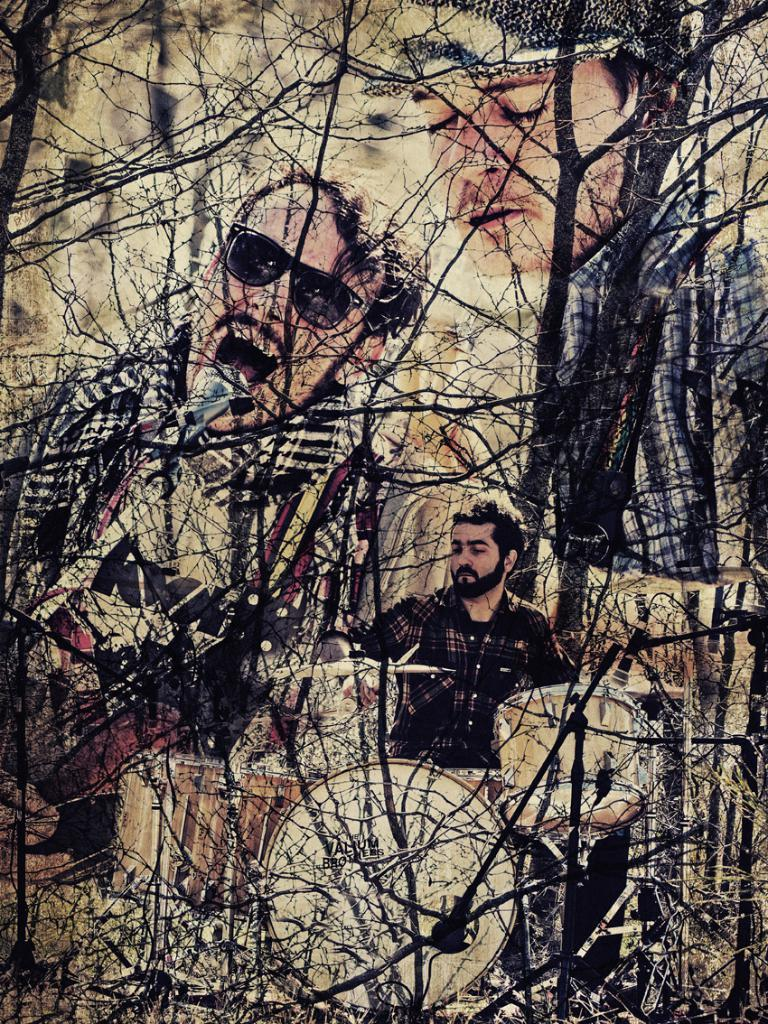How many people are in the image? There are persons in the image, but the exact number is not specified. What can be seen in the image besides the persons? There are branches of trees in the image. How many ducks are visible in the image? There are no ducks present in the image; it only features persons and branches of trees. 